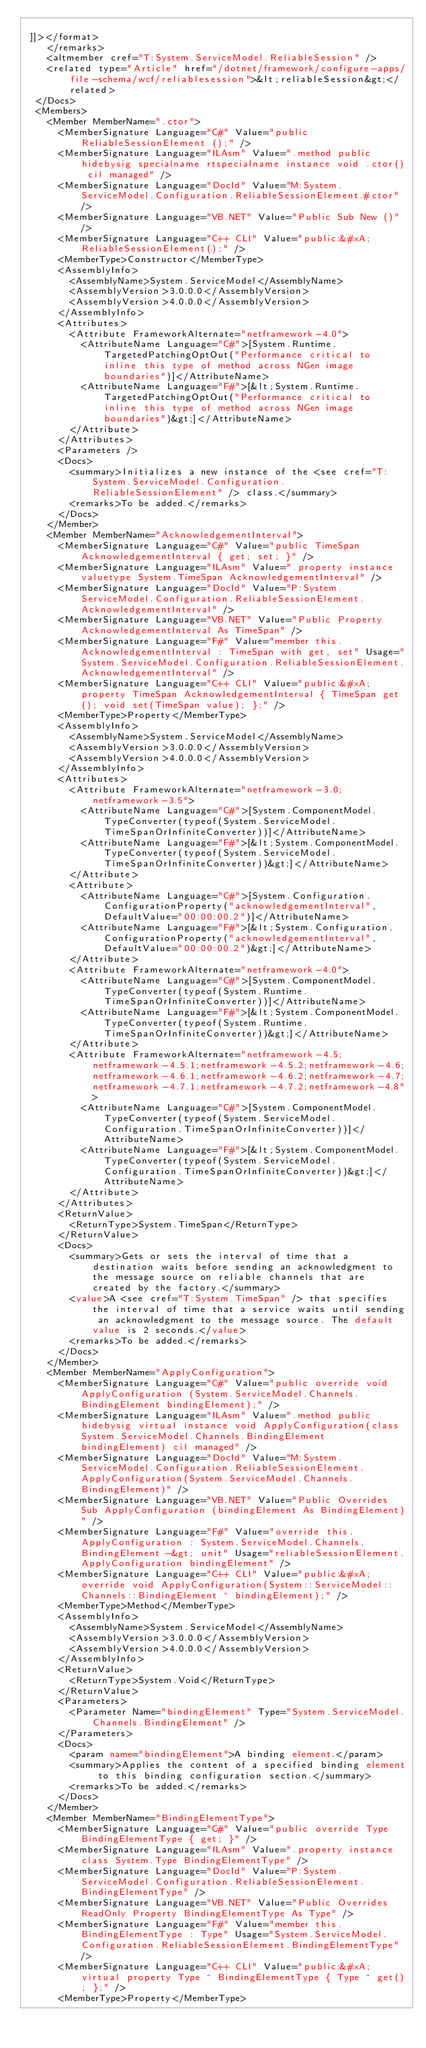<code> <loc_0><loc_0><loc_500><loc_500><_XML_>  
 ]]></format>
    </remarks>
    <altmember cref="T:System.ServiceModel.ReliableSession" />
    <related type="Article" href="/dotnet/framework/configure-apps/file-schema/wcf/reliablesession">&lt;reliableSession&gt;</related>
  </Docs>
  <Members>
    <Member MemberName=".ctor">
      <MemberSignature Language="C#" Value="public ReliableSessionElement ();" />
      <MemberSignature Language="ILAsm" Value=".method public hidebysig specialname rtspecialname instance void .ctor() cil managed" />
      <MemberSignature Language="DocId" Value="M:System.ServiceModel.Configuration.ReliableSessionElement.#ctor" />
      <MemberSignature Language="VB.NET" Value="Public Sub New ()" />
      <MemberSignature Language="C++ CLI" Value="public:&#xA; ReliableSessionElement();" />
      <MemberType>Constructor</MemberType>
      <AssemblyInfo>
        <AssemblyName>System.ServiceModel</AssemblyName>
        <AssemblyVersion>3.0.0.0</AssemblyVersion>
        <AssemblyVersion>4.0.0.0</AssemblyVersion>
      </AssemblyInfo>
      <Attributes>
        <Attribute FrameworkAlternate="netframework-4.0">
          <AttributeName Language="C#">[System.Runtime.TargetedPatchingOptOut("Performance critical to inline this type of method across NGen image boundaries")]</AttributeName>
          <AttributeName Language="F#">[&lt;System.Runtime.TargetedPatchingOptOut("Performance critical to inline this type of method across NGen image boundaries")&gt;]</AttributeName>
        </Attribute>
      </Attributes>
      <Parameters />
      <Docs>
        <summary>Initializes a new instance of the <see cref="T:System.ServiceModel.Configuration.ReliableSessionElement" /> class.</summary>
        <remarks>To be added.</remarks>
      </Docs>
    </Member>
    <Member MemberName="AcknowledgementInterval">
      <MemberSignature Language="C#" Value="public TimeSpan AcknowledgementInterval { get; set; }" />
      <MemberSignature Language="ILAsm" Value=".property instance valuetype System.TimeSpan AcknowledgementInterval" />
      <MemberSignature Language="DocId" Value="P:System.ServiceModel.Configuration.ReliableSessionElement.AcknowledgementInterval" />
      <MemberSignature Language="VB.NET" Value="Public Property AcknowledgementInterval As TimeSpan" />
      <MemberSignature Language="F#" Value="member this.AcknowledgementInterval : TimeSpan with get, set" Usage="System.ServiceModel.Configuration.ReliableSessionElement.AcknowledgementInterval" />
      <MemberSignature Language="C++ CLI" Value="public:&#xA; property TimeSpan AcknowledgementInterval { TimeSpan get(); void set(TimeSpan value); };" />
      <MemberType>Property</MemberType>
      <AssemblyInfo>
        <AssemblyName>System.ServiceModel</AssemblyName>
        <AssemblyVersion>3.0.0.0</AssemblyVersion>
        <AssemblyVersion>4.0.0.0</AssemblyVersion>
      </AssemblyInfo>
      <Attributes>
        <Attribute FrameworkAlternate="netframework-3.0;netframework-3.5">
          <AttributeName Language="C#">[System.ComponentModel.TypeConverter(typeof(System.ServiceModel.TimeSpanOrInfiniteConverter))]</AttributeName>
          <AttributeName Language="F#">[&lt;System.ComponentModel.TypeConverter(typeof(System.ServiceModel.TimeSpanOrInfiniteConverter))&gt;]</AttributeName>
        </Attribute>
        <Attribute>
          <AttributeName Language="C#">[System.Configuration.ConfigurationProperty("acknowledgementInterval", DefaultValue="00:00:00.2")]</AttributeName>
          <AttributeName Language="F#">[&lt;System.Configuration.ConfigurationProperty("acknowledgementInterval", DefaultValue="00:00:00.2")&gt;]</AttributeName>
        </Attribute>
        <Attribute FrameworkAlternate="netframework-4.0">
          <AttributeName Language="C#">[System.ComponentModel.TypeConverter(typeof(System.Runtime.TimeSpanOrInfiniteConverter))]</AttributeName>
          <AttributeName Language="F#">[&lt;System.ComponentModel.TypeConverter(typeof(System.Runtime.TimeSpanOrInfiniteConverter))&gt;]</AttributeName>
        </Attribute>
        <Attribute FrameworkAlternate="netframework-4.5;netframework-4.5.1;netframework-4.5.2;netframework-4.6;netframework-4.6.1;netframework-4.6.2;netframework-4.7;netframework-4.7.1;netframework-4.7.2;netframework-4.8">
          <AttributeName Language="C#">[System.ComponentModel.TypeConverter(typeof(System.ServiceModel.Configuration.TimeSpanOrInfiniteConverter))]</AttributeName>
          <AttributeName Language="F#">[&lt;System.ComponentModel.TypeConverter(typeof(System.ServiceModel.Configuration.TimeSpanOrInfiniteConverter))&gt;]</AttributeName>
        </Attribute>
      </Attributes>
      <ReturnValue>
        <ReturnType>System.TimeSpan</ReturnType>
      </ReturnValue>
      <Docs>
        <summary>Gets or sets the interval of time that a destination waits before sending an acknowledgment to the message source on reliable channels that are created by the factory.</summary>
        <value>A <see cref="T:System.TimeSpan" /> that specifies the interval of time that a service waits until sending an acknowledgment to the message source. The default value is 2 seconds.</value>
        <remarks>To be added.</remarks>
      </Docs>
    </Member>
    <Member MemberName="ApplyConfiguration">
      <MemberSignature Language="C#" Value="public override void ApplyConfiguration (System.ServiceModel.Channels.BindingElement bindingElement);" />
      <MemberSignature Language="ILAsm" Value=".method public hidebysig virtual instance void ApplyConfiguration(class System.ServiceModel.Channels.BindingElement bindingElement) cil managed" />
      <MemberSignature Language="DocId" Value="M:System.ServiceModel.Configuration.ReliableSessionElement.ApplyConfiguration(System.ServiceModel.Channels.BindingElement)" />
      <MemberSignature Language="VB.NET" Value="Public Overrides Sub ApplyConfiguration (bindingElement As BindingElement)" />
      <MemberSignature Language="F#" Value="override this.ApplyConfiguration : System.ServiceModel.Channels.BindingElement -&gt; unit" Usage="reliableSessionElement.ApplyConfiguration bindingElement" />
      <MemberSignature Language="C++ CLI" Value="public:&#xA; override void ApplyConfiguration(System::ServiceModel::Channels::BindingElement ^ bindingElement);" />
      <MemberType>Method</MemberType>
      <AssemblyInfo>
        <AssemblyName>System.ServiceModel</AssemblyName>
        <AssemblyVersion>3.0.0.0</AssemblyVersion>
        <AssemblyVersion>4.0.0.0</AssemblyVersion>
      </AssemblyInfo>
      <ReturnValue>
        <ReturnType>System.Void</ReturnType>
      </ReturnValue>
      <Parameters>
        <Parameter Name="bindingElement" Type="System.ServiceModel.Channels.BindingElement" />
      </Parameters>
      <Docs>
        <param name="bindingElement">A binding element.</param>
        <summary>Applies the content of a specified binding element to this binding configuration section.</summary>
        <remarks>To be added.</remarks>
      </Docs>
    </Member>
    <Member MemberName="BindingElementType">
      <MemberSignature Language="C#" Value="public override Type BindingElementType { get; }" />
      <MemberSignature Language="ILAsm" Value=".property instance class System.Type BindingElementType" />
      <MemberSignature Language="DocId" Value="P:System.ServiceModel.Configuration.ReliableSessionElement.BindingElementType" />
      <MemberSignature Language="VB.NET" Value="Public Overrides ReadOnly Property BindingElementType As Type" />
      <MemberSignature Language="F#" Value="member this.BindingElementType : Type" Usage="System.ServiceModel.Configuration.ReliableSessionElement.BindingElementType" />
      <MemberSignature Language="C++ CLI" Value="public:&#xA; virtual property Type ^ BindingElementType { Type ^ get(); };" />
      <MemberType>Property</MemberType></code> 